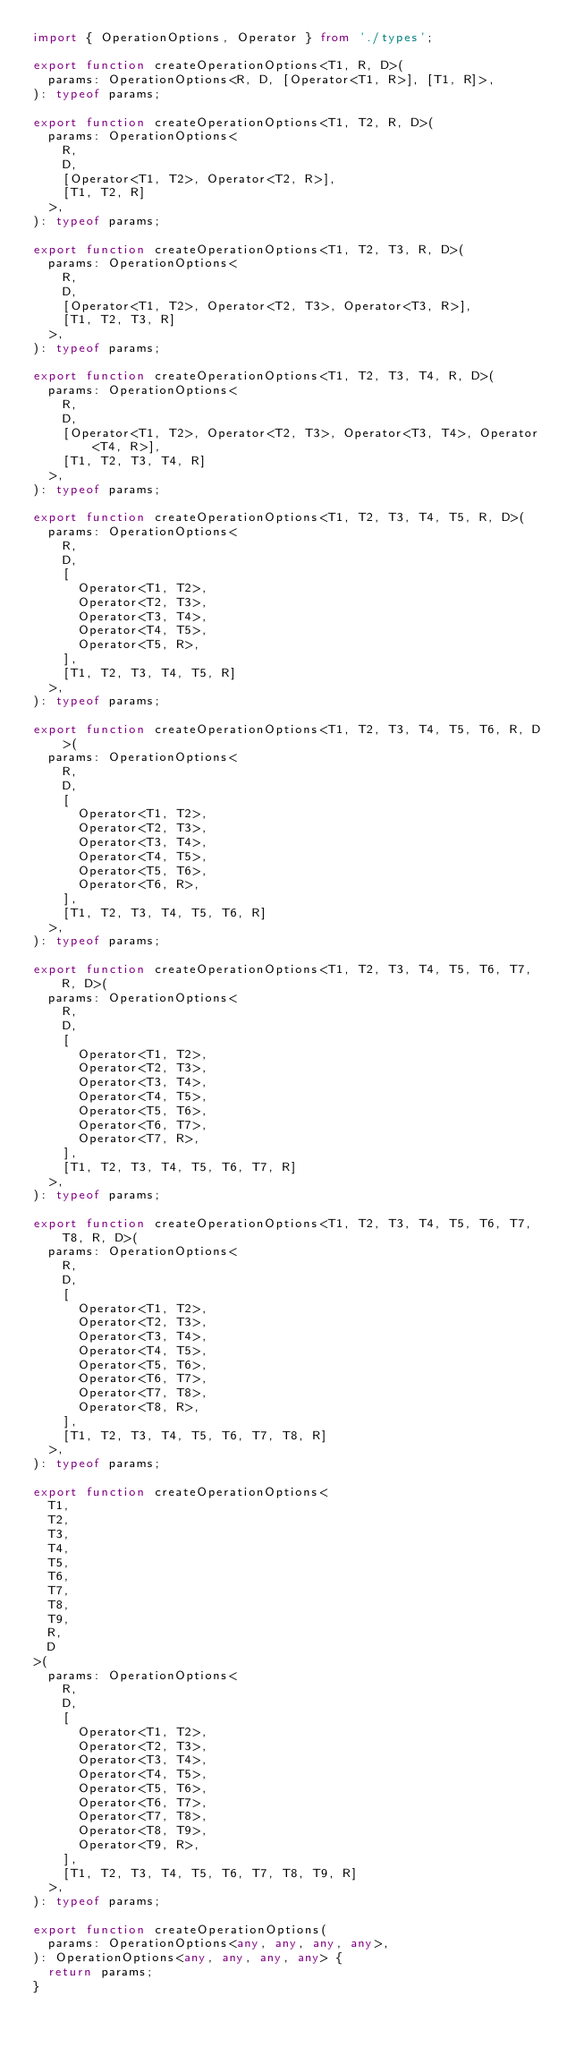Convert code to text. <code><loc_0><loc_0><loc_500><loc_500><_TypeScript_>import { OperationOptions, Operator } from './types';

export function createOperationOptions<T1, R, D>(
  params: OperationOptions<R, D, [Operator<T1, R>], [T1, R]>,
): typeof params;

export function createOperationOptions<T1, T2, R, D>(
  params: OperationOptions<
    R,
    D,
    [Operator<T1, T2>, Operator<T2, R>],
    [T1, T2, R]
  >,
): typeof params;

export function createOperationOptions<T1, T2, T3, R, D>(
  params: OperationOptions<
    R,
    D,
    [Operator<T1, T2>, Operator<T2, T3>, Operator<T3, R>],
    [T1, T2, T3, R]
  >,
): typeof params;

export function createOperationOptions<T1, T2, T3, T4, R, D>(
  params: OperationOptions<
    R,
    D,
    [Operator<T1, T2>, Operator<T2, T3>, Operator<T3, T4>, Operator<T4, R>],
    [T1, T2, T3, T4, R]
  >,
): typeof params;

export function createOperationOptions<T1, T2, T3, T4, T5, R, D>(
  params: OperationOptions<
    R,
    D,
    [
      Operator<T1, T2>,
      Operator<T2, T3>,
      Operator<T3, T4>,
      Operator<T4, T5>,
      Operator<T5, R>,
    ],
    [T1, T2, T3, T4, T5, R]
  >,
): typeof params;

export function createOperationOptions<T1, T2, T3, T4, T5, T6, R, D>(
  params: OperationOptions<
    R,
    D,
    [
      Operator<T1, T2>,
      Operator<T2, T3>,
      Operator<T3, T4>,
      Operator<T4, T5>,
      Operator<T5, T6>,
      Operator<T6, R>,
    ],
    [T1, T2, T3, T4, T5, T6, R]
  >,
): typeof params;

export function createOperationOptions<T1, T2, T3, T4, T5, T6, T7, R, D>(
  params: OperationOptions<
    R,
    D,
    [
      Operator<T1, T2>,
      Operator<T2, T3>,
      Operator<T3, T4>,
      Operator<T4, T5>,
      Operator<T5, T6>,
      Operator<T6, T7>,
      Operator<T7, R>,
    ],
    [T1, T2, T3, T4, T5, T6, T7, R]
  >,
): typeof params;

export function createOperationOptions<T1, T2, T3, T4, T5, T6, T7, T8, R, D>(
  params: OperationOptions<
    R,
    D,
    [
      Operator<T1, T2>,
      Operator<T2, T3>,
      Operator<T3, T4>,
      Operator<T4, T5>,
      Operator<T5, T6>,
      Operator<T6, T7>,
      Operator<T7, T8>,
      Operator<T8, R>,
    ],
    [T1, T2, T3, T4, T5, T6, T7, T8, R]
  >,
): typeof params;

export function createOperationOptions<
  T1,
  T2,
  T3,
  T4,
  T5,
  T6,
  T7,
  T8,
  T9,
  R,
  D
>(
  params: OperationOptions<
    R,
    D,
    [
      Operator<T1, T2>,
      Operator<T2, T3>,
      Operator<T3, T4>,
      Operator<T4, T5>,
      Operator<T5, T6>,
      Operator<T6, T7>,
      Operator<T7, T8>,
      Operator<T8, T9>,
      Operator<T9, R>,
    ],
    [T1, T2, T3, T4, T5, T6, T7, T8, T9, R]
  >,
): typeof params;

export function createOperationOptions(
  params: OperationOptions<any, any, any, any>,
): OperationOptions<any, any, any, any> {
  return params;
}
</code> 